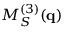Convert formula to latex. <formula><loc_0><loc_0><loc_500><loc_500>M _ { S } ^ { ( 3 ) } ( q )</formula> 